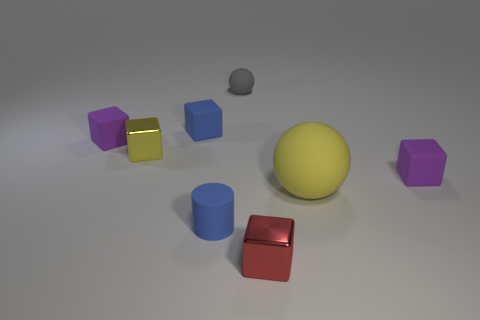How big is the sphere that is in front of the tiny purple matte block to the left of the shiny thing that is in front of the large yellow rubber sphere?
Offer a terse response. Large. Do the blue block and the purple thing left of the small blue rubber cube have the same material?
Make the answer very short. Yes. What is the size of the red thing that is the same material as the yellow cube?
Ensure brevity in your answer.  Small. Are there any large purple things of the same shape as the red object?
Keep it short and to the point. No. What number of objects are either tiny purple matte things that are to the left of the red metallic block or cylinders?
Your response must be concise. 2. There is a metallic thing behind the big rubber sphere; does it have the same color as the ball that is on the right side of the red metallic cube?
Ensure brevity in your answer.  Yes. The yellow rubber thing has what size?
Provide a succinct answer. Large. How many large things are either purple matte balls or purple matte objects?
Ensure brevity in your answer.  0. The rubber ball that is the same size as the red cube is what color?
Provide a short and direct response. Gray. What number of other things are the same shape as the small yellow thing?
Your answer should be compact. 4. 